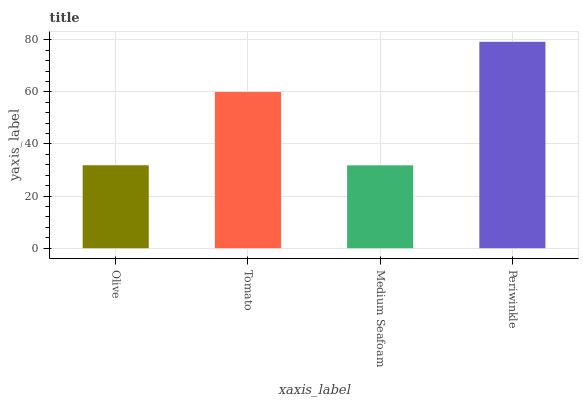Is Medium Seafoam the minimum?
Answer yes or no. Yes. Is Periwinkle the maximum?
Answer yes or no. Yes. Is Tomato the minimum?
Answer yes or no. No. Is Tomato the maximum?
Answer yes or no. No. Is Tomato greater than Olive?
Answer yes or no. Yes. Is Olive less than Tomato?
Answer yes or no. Yes. Is Olive greater than Tomato?
Answer yes or no. No. Is Tomato less than Olive?
Answer yes or no. No. Is Tomato the high median?
Answer yes or no. Yes. Is Olive the low median?
Answer yes or no. Yes. Is Periwinkle the high median?
Answer yes or no. No. Is Tomato the low median?
Answer yes or no. No. 